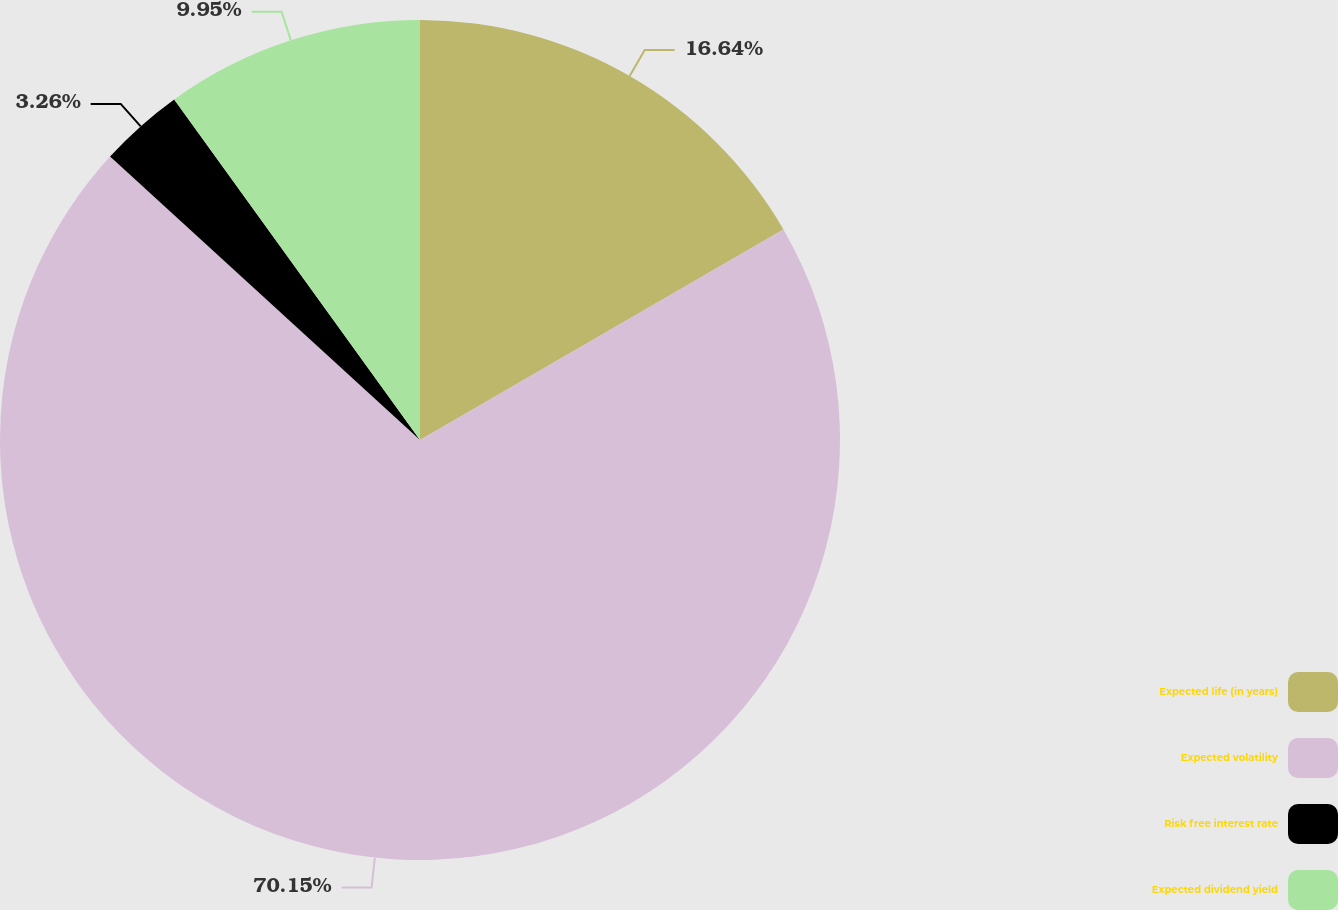Convert chart. <chart><loc_0><loc_0><loc_500><loc_500><pie_chart><fcel>Expected life (in years)<fcel>Expected volatility<fcel>Risk free interest rate<fcel>Expected dividend yield<nl><fcel>16.64%<fcel>70.15%<fcel>3.26%<fcel>9.95%<nl></chart> 